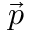<formula> <loc_0><loc_0><loc_500><loc_500>\vec { p }</formula> 